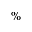Convert formula to latex. <formula><loc_0><loc_0><loc_500><loc_500>\%</formula> 